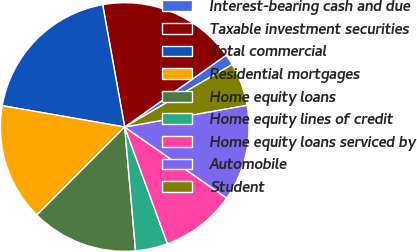Convert chart. <chart><loc_0><loc_0><loc_500><loc_500><pie_chart><fcel>Interest-bearing cash and due<fcel>Taxable investment securities<fcel>Total commercial<fcel>Residential mortgages<fcel>Home equity loans<fcel>Home equity lines of credit<fcel>Home equity loans serviced by<fcel>Automobile<fcel>Student<nl><fcel>1.42%<fcel>18.04%<fcel>19.42%<fcel>15.27%<fcel>13.88%<fcel>4.19%<fcel>9.73%<fcel>12.5%<fcel>5.57%<nl></chart> 